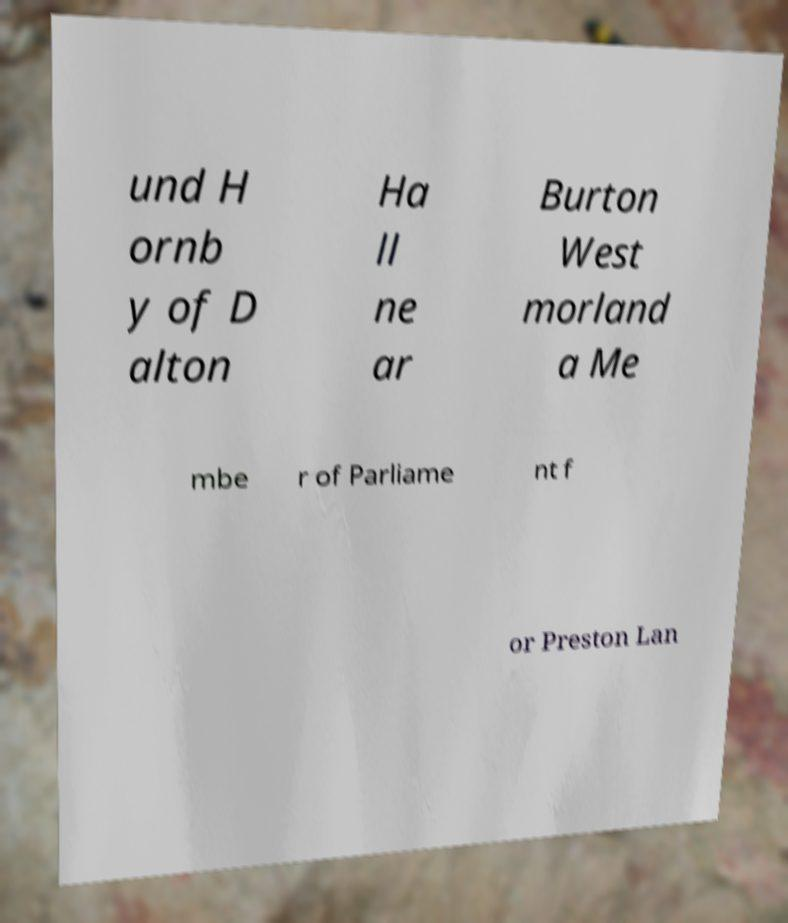Could you extract and type out the text from this image? und H ornb y of D alton Ha ll ne ar Burton West morland a Me mbe r of Parliame nt f or Preston Lan 